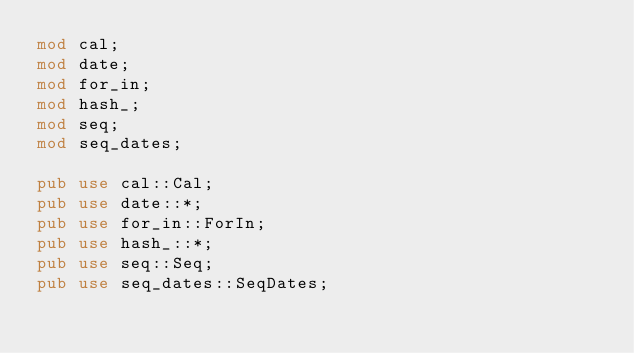Convert code to text. <code><loc_0><loc_0><loc_500><loc_500><_Rust_>mod cal;
mod date;
mod for_in;
mod hash_;
mod seq;
mod seq_dates;

pub use cal::Cal;
pub use date::*;
pub use for_in::ForIn;
pub use hash_::*;
pub use seq::Seq;
pub use seq_dates::SeqDates;
</code> 